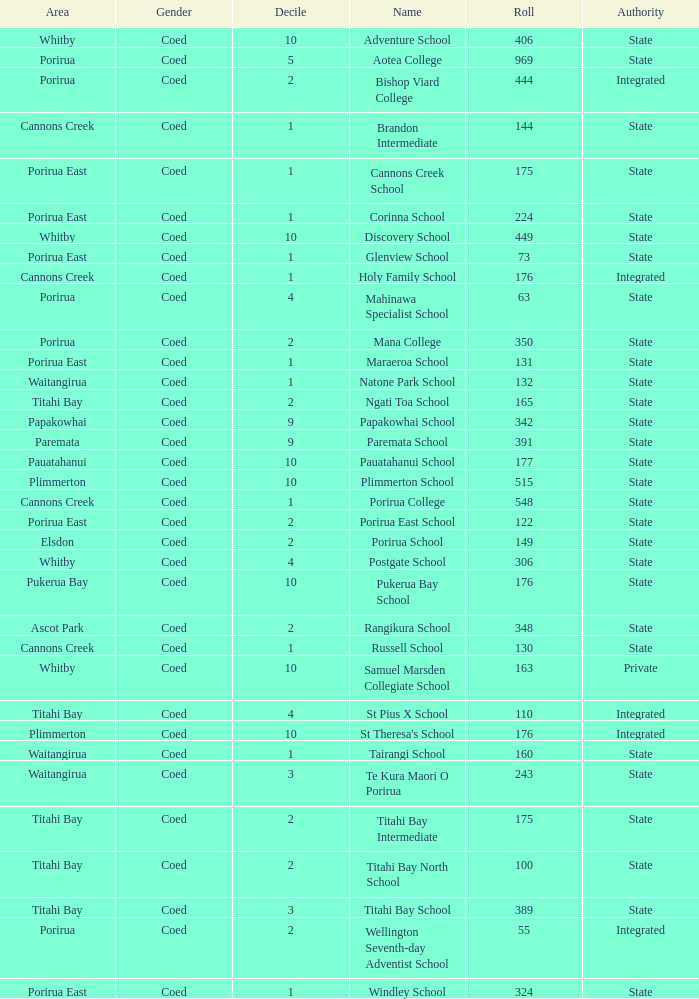What integrated school had a decile of 2 and a roll larger than 55? Bishop Viard College. Can you parse all the data within this table? {'header': ['Area', 'Gender', 'Decile', 'Name', 'Roll', 'Authority'], 'rows': [['Whitby', 'Coed', '10', 'Adventure School', '406', 'State'], ['Porirua', 'Coed', '5', 'Aotea College', '969', 'State'], ['Porirua', 'Coed', '2', 'Bishop Viard College', '444', 'Integrated'], ['Cannons Creek', 'Coed', '1', 'Brandon Intermediate', '144', 'State'], ['Porirua East', 'Coed', '1', 'Cannons Creek School', '175', 'State'], ['Porirua East', 'Coed', '1', 'Corinna School', '224', 'State'], ['Whitby', 'Coed', '10', 'Discovery School', '449', 'State'], ['Porirua East', 'Coed', '1', 'Glenview School', '73', 'State'], ['Cannons Creek', 'Coed', '1', 'Holy Family School', '176', 'Integrated'], ['Porirua', 'Coed', '4', 'Mahinawa Specialist School', '63', 'State'], ['Porirua', 'Coed', '2', 'Mana College', '350', 'State'], ['Porirua East', 'Coed', '1', 'Maraeroa School', '131', 'State'], ['Waitangirua', 'Coed', '1', 'Natone Park School', '132', 'State'], ['Titahi Bay', 'Coed', '2', 'Ngati Toa School', '165', 'State'], ['Papakowhai', 'Coed', '9', 'Papakowhai School', '342', 'State'], ['Paremata', 'Coed', '9', 'Paremata School', '391', 'State'], ['Pauatahanui', 'Coed', '10', 'Pauatahanui School', '177', 'State'], ['Plimmerton', 'Coed', '10', 'Plimmerton School', '515', 'State'], ['Cannons Creek', 'Coed', '1', 'Porirua College', '548', 'State'], ['Porirua East', 'Coed', '2', 'Porirua East School', '122', 'State'], ['Elsdon', 'Coed', '2', 'Porirua School', '149', 'State'], ['Whitby', 'Coed', '4', 'Postgate School', '306', 'State'], ['Pukerua Bay', 'Coed', '10', 'Pukerua Bay School', '176', 'State'], ['Ascot Park', 'Coed', '2', 'Rangikura School', '348', 'State'], ['Cannons Creek', 'Coed', '1', 'Russell School', '130', 'State'], ['Whitby', 'Coed', '10', 'Samuel Marsden Collegiate School', '163', 'Private'], ['Titahi Bay', 'Coed', '4', 'St Pius X School', '110', 'Integrated'], ['Plimmerton', 'Coed', '10', "St Theresa's School", '176', 'Integrated'], ['Waitangirua', 'Coed', '1', 'Tairangi School', '160', 'State'], ['Waitangirua', 'Coed', '3', 'Te Kura Maori O Porirua', '243', 'State'], ['Titahi Bay', 'Coed', '2', 'Titahi Bay Intermediate', '175', 'State'], ['Titahi Bay', 'Coed', '2', 'Titahi Bay North School', '100', 'State'], ['Titahi Bay', 'Coed', '3', 'Titahi Bay School', '389', 'State'], ['Porirua', 'Coed', '2', 'Wellington Seventh-day Adventist School', '55', 'Integrated'], ['Porirua East', 'Coed', '1', 'Windley School', '324', 'State']]} 